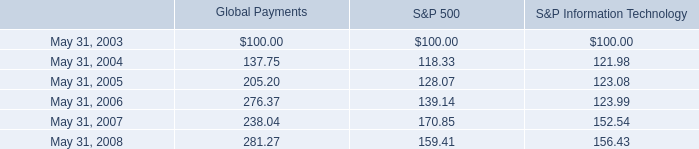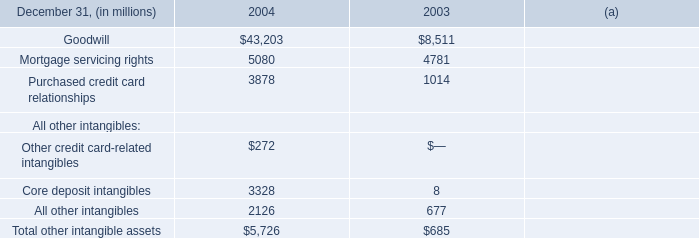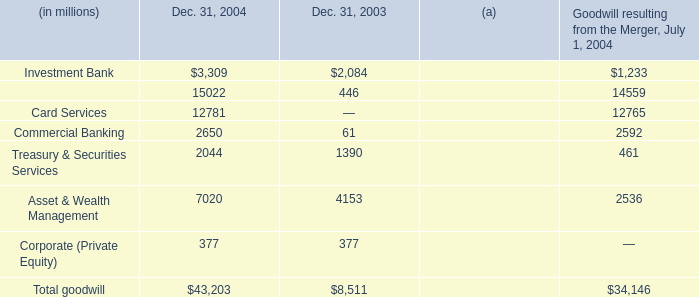what is the roi of global payments from 2004 to 2005? 
Computations: ((205.20 - 137.75) / 137.75)
Answer: 0.48966. 